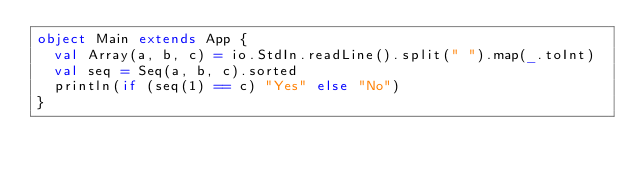Convert code to text. <code><loc_0><loc_0><loc_500><loc_500><_Scala_>object Main extends App {
  val Array(a, b, c) = io.StdIn.readLine().split(" ").map(_.toInt)
  val seq = Seq(a, b, c).sorted
  println(if (seq(1) == c) "Yes" else "No")
}</code> 